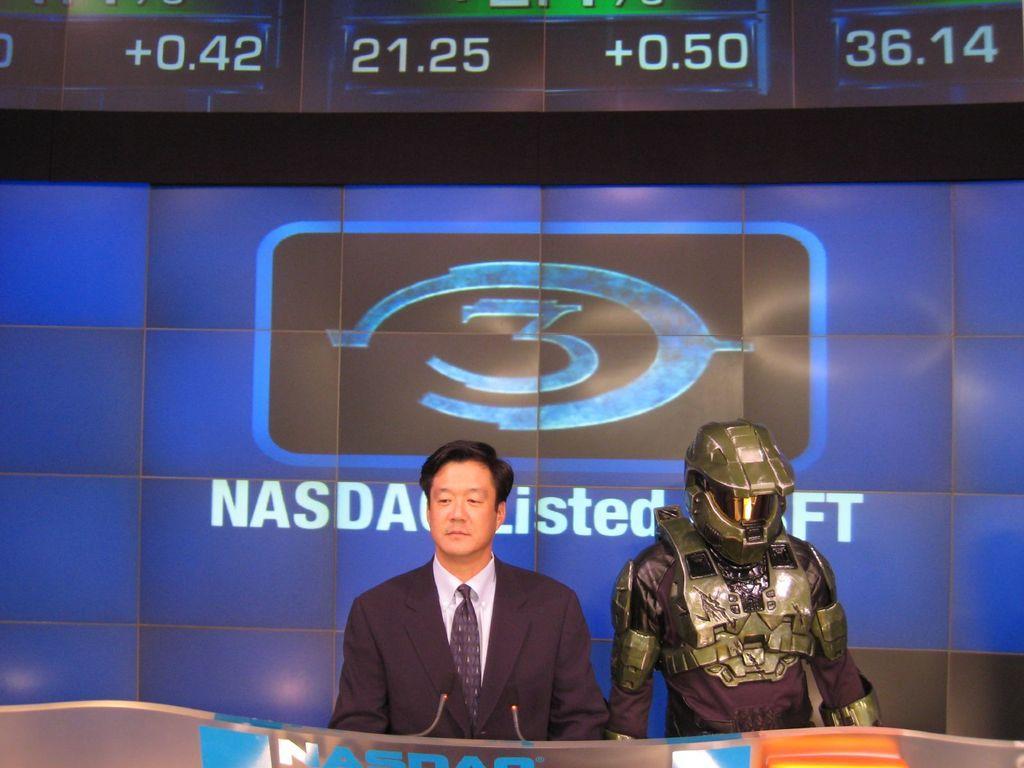Can you describe this image briefly? In this image we can see there are two people standing behind a podium which has microphones and one among them is wearing a costume, behind them there is a screen which contains some text and a logo. 